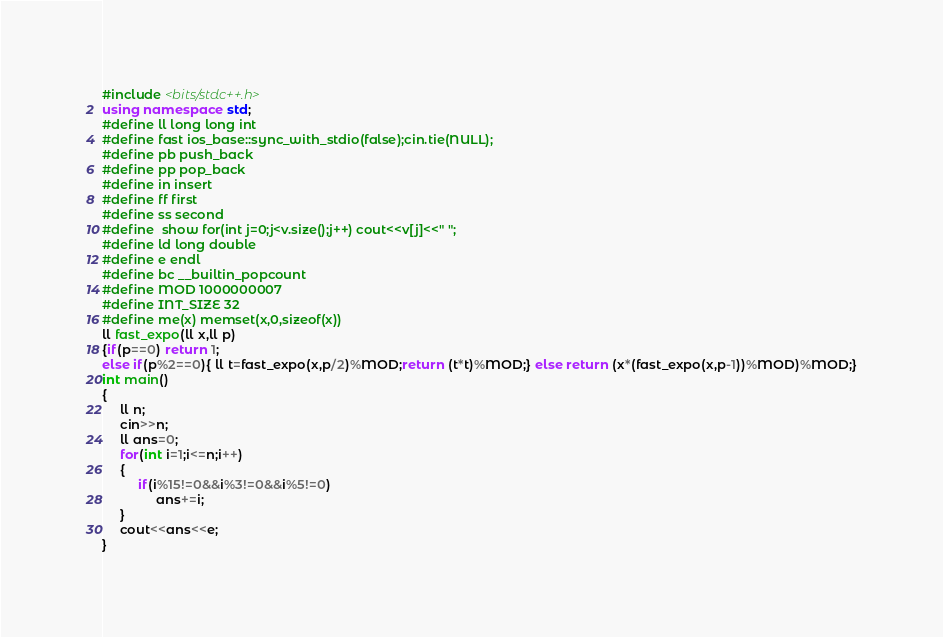Convert code to text. <code><loc_0><loc_0><loc_500><loc_500><_C++_>#include <bits/stdc++.h>
using namespace std;
#define ll long long int
#define fast ios_base::sync_with_stdio(false);cin.tie(NULL);
#define pb push_back
#define pp pop_back
#define in insert
#define ff first
#define ss second
#define  show for(int j=0;j<v.size();j++) cout<<v[j]<<" ";
#define ld long double
#define e endl
#define bc __builtin_popcount
#define MOD 1000000007
#define INT_SIZE 32
#define me(x) memset(x,0,sizeof(x))
ll fast_expo(ll x,ll p)
{if(p==0) return 1;
else if(p%2==0){ ll t=fast_expo(x,p/2)%MOD;return (t*t)%MOD;} else return (x*(fast_expo(x,p-1))%MOD)%MOD;}
int main()
{
     ll n;
     cin>>n;
     ll ans=0;
     for(int i=1;i<=n;i++)
     {
          if(i%15!=0&&i%3!=0&&i%5!=0)
               ans+=i;
     }
     cout<<ans<<e;
}



</code> 